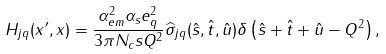<formula> <loc_0><loc_0><loc_500><loc_500>H _ { j q } ( x ^ { \prime } , x ) = \frac { \alpha _ { e m } ^ { 2 } \alpha _ { s } e _ { q } ^ { 2 } } { 3 \pi N _ { c } s Q ^ { 2 } } \widehat { \sigma } _ { j q } ( \hat { s } , \hat { t } , \hat { u } ) \delta \left ( \hat { s } + \hat { t } + \hat { u } - Q ^ { 2 } \right ) ,</formula> 